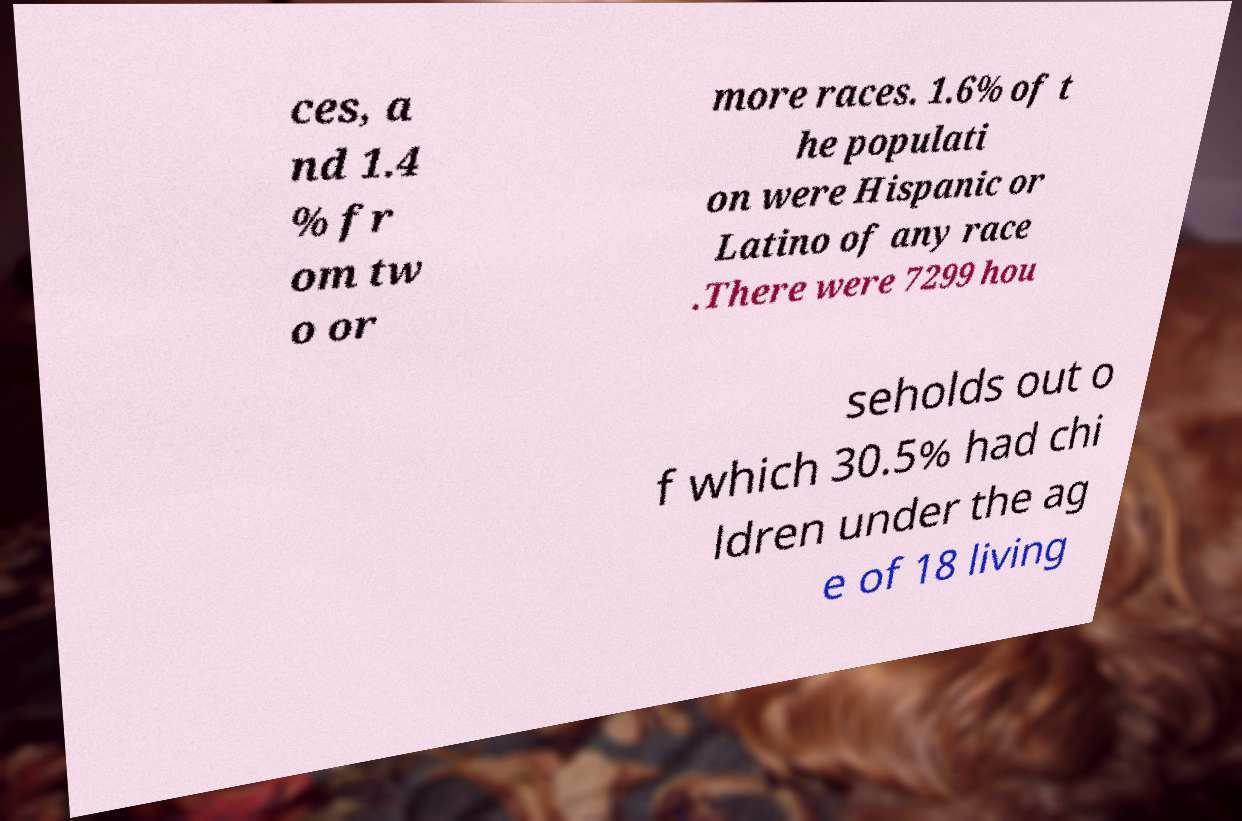What messages or text are displayed in this image? I need them in a readable, typed format. ces, a nd 1.4 % fr om tw o or more races. 1.6% of t he populati on were Hispanic or Latino of any race .There were 7299 hou seholds out o f which 30.5% had chi ldren under the ag e of 18 living 